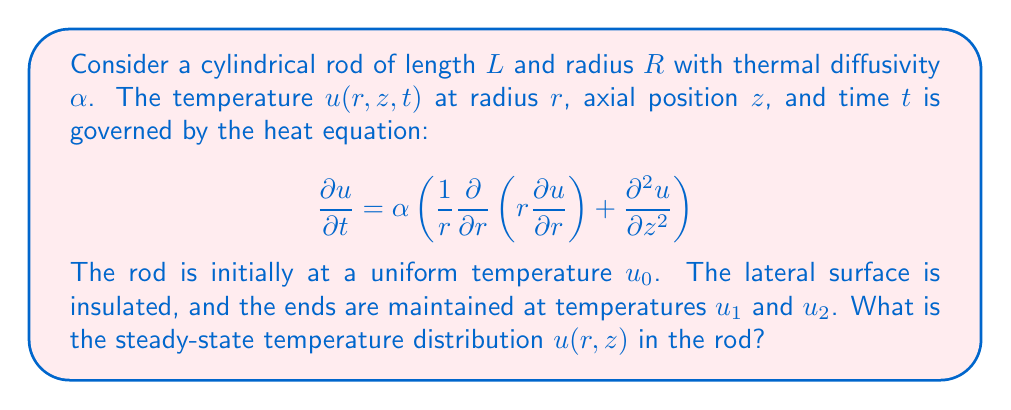What is the answer to this math problem? To solve this problem, we'll follow these steps:

1) For the steady-state solution, $\frac{\partial u}{\partial t} = 0$. The heat equation becomes:

   $$0 = \frac{1}{r}\frac{\partial}{\partial r}\left(r\frac{\partial u}{\partial r}\right) + \frac{\partial^2 u}{\partial z^2}$$

2) The insulated lateral surface means $\frac{\partial u}{\partial r} = 0$ at $r = R$. This, combined with the symmetry of the problem, suggests that $u$ is independent of $r$.

3) Therefore, the equation simplifies to:

   $$\frac{d^2 u}{dz^2} = 0$$

4) The general solution to this equation is:

   $$u(z) = Az + B$$

   where $A$ and $B$ are constants to be determined from the boundary conditions.

5) The boundary conditions are:
   - At $z = 0$, $u = u_1$
   - At $z = L$, $u = u_2$

6) Applying these conditions:
   - $u_1 = A(0) + B = B$
   - $u_2 = A(L) + B$

7) From these, we can determine:
   - $B = u_1$
   - $A = \frac{u_2 - u_1}{L}$

8) Therefore, the steady-state temperature distribution is:

   $$u(z) = \frac{u_2 - u_1}{L}z + u_1$$

This linear distribution represents a constant temperature gradient along the length of the rod.
Answer: $u(z) = \frac{u_2 - u_1}{L}z + u_1$ 